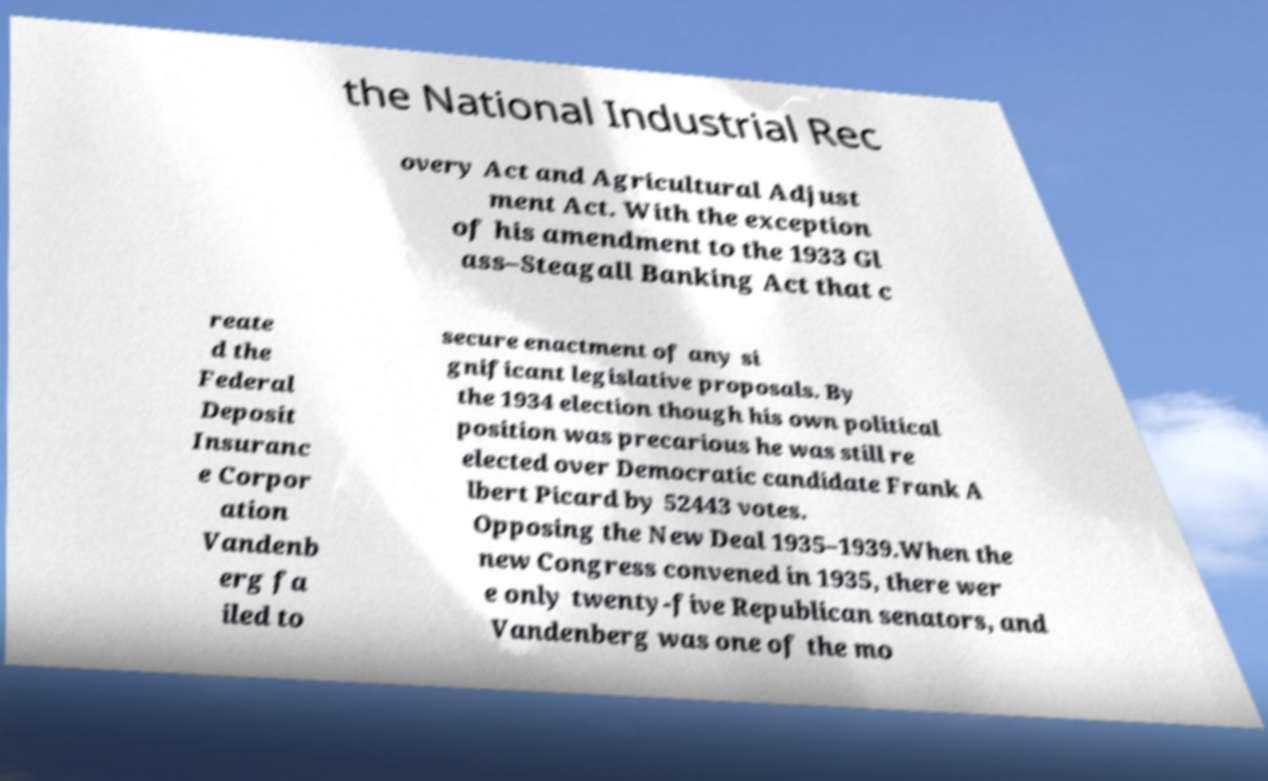Can you accurately transcribe the text from the provided image for me? the National Industrial Rec overy Act and Agricultural Adjust ment Act. With the exception of his amendment to the 1933 Gl ass–Steagall Banking Act that c reate d the Federal Deposit Insuranc e Corpor ation Vandenb erg fa iled to secure enactment of any si gnificant legislative proposals. By the 1934 election though his own political position was precarious he was still re elected over Democratic candidate Frank A lbert Picard by 52443 votes. Opposing the New Deal 1935–1939.When the new Congress convened in 1935, there wer e only twenty-five Republican senators, and Vandenberg was one of the mo 